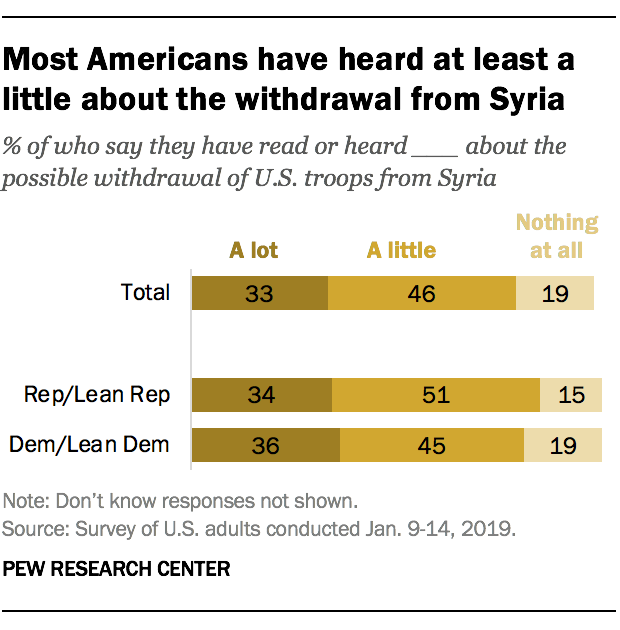Highlight a few significant elements in this photo. The average of all the bars in the Total category is less than the largest value of A little bars. 